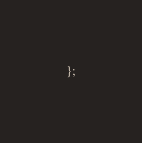Convert code to text. <code><loc_0><loc_0><loc_500><loc_500><_JavaScript_>};
</code> 